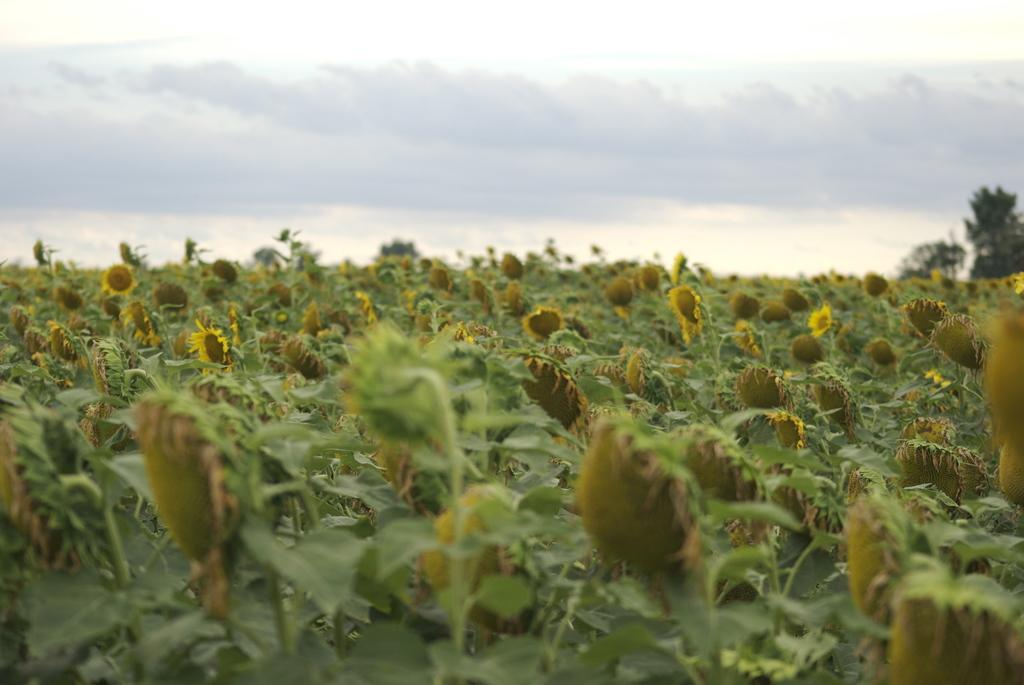What is the main subject of the picture? The main subject of the picture is a sunflower farm field. What can be seen on the top right side of the image? There are trees on the top right side of the image. What is visible in the sky in the picture? There are clouds in the sky. Can you tell me how many sheets are hanging on the clothesline in the image? There is no clothesline or sheet present in the image; it features a sunflower farm field with trees and clouds in the sky. Is there a ship visible in the image? No, there is no ship present in the image. 